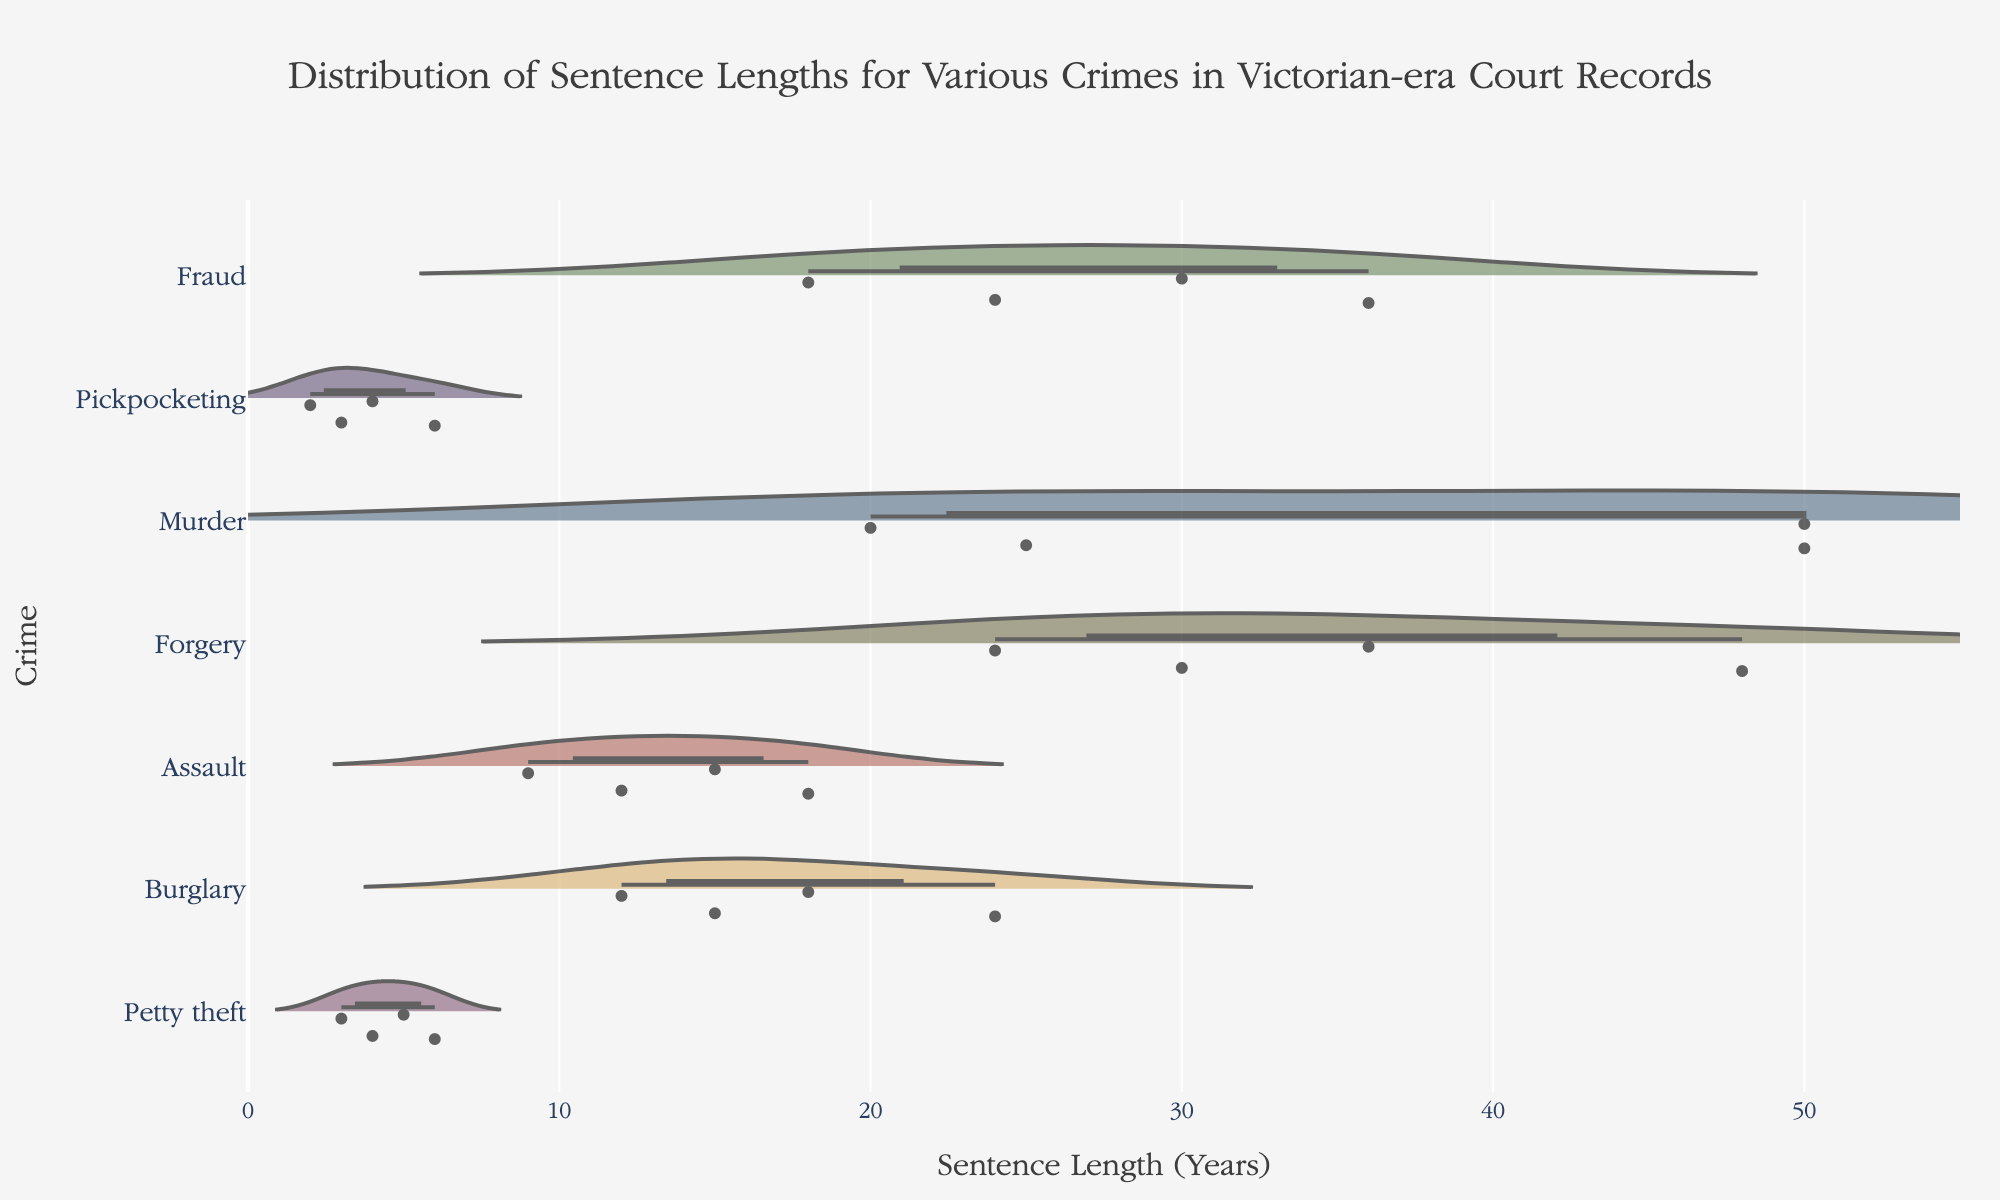What is the title of the plot? The title of the plot usually appears at the top of the figure. It provides a brief summary of what the figure represents. Here, the title states it shows the distribution of sentence lengths for various crimes in Victorian-era court records.
Answer: Distribution of Sentence Lengths for Various Crimes in Victorian-era Court Records What crime category has the longest maximum sentence length? To find the crime category with the longest maximum sentence length, inspect each category in the plot. The life sentences, converted to 50 years, are visually the longest.
Answer: Murder Which crime has the shortest sentence lengths? By examining the plot, we look for the category where the data points and density are situated closest to the lower end of the x-axis.
Answer: Pickpocketing How many years is a 'Life' sentence considered in this plot? The ability to interpret the term 'Life' in this context is necessary. Here, it has been converted to a definitive number for uniformity. By rechecking the provided context or looking at the converted values in the plot, this term is equated to 50 years.
Answer: 50 years What is the most common sentence length for Forgery? Examining the density and clustering of data points for Forgery within the plot shows where sentences concentrate the most.
Answer: 30 years Which two crimes have sentences that go up to 30 years? By cross-verifying the density and visible point clusters that extend up to the 30-year point, we identify the relevant crimes.
Answer: Forgery and Fraud What is the mean sentence length for Assault? For this, one needs to look at the horizontal line within the Assault category trace that represents the mean value.
Answer: 13.5 years How do the sentence lengths for Burglary compare to those for Petty Theft? A comparative analysis involves observing where data points and densities lie on the x-axis for both Burglary and Petty Theft. Burglary sentences are much longer and more spread out compared to Petty Theft.
Answer: Burglary sentences are generally longer than Petty Theft Which crime shows a higher variability in sentence length: Fraud or Pickpocketing? Variability is assessed by the span of the data points in each category. A wider span indicates greater variability.
Answer: Fraud Do any crimes have overlapping sentence lengths? If so, which ones? Assess the plot to check if the ranges of sentence lengths for different crimes visually overlap. Multiple crimes exhibit this, particularly sentences in the lower ranges overlapping among crimes like Fraud, Forgery, and Burglary.
Answer: Yes, multiple overlaps including Fraud, Forgery, and Burglary 